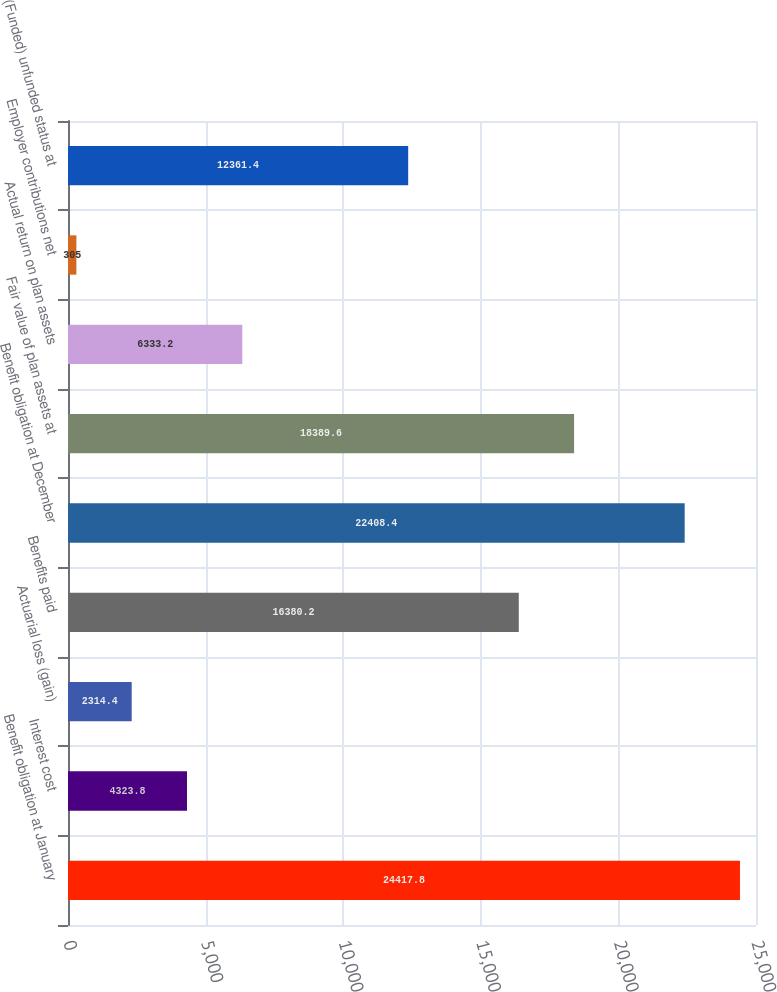<chart> <loc_0><loc_0><loc_500><loc_500><bar_chart><fcel>Benefit obligation at January<fcel>Interest cost<fcel>Actuarial loss (gain)<fcel>Benefits paid<fcel>Benefit obligation at December<fcel>Fair value of plan assets at<fcel>Actual return on plan assets<fcel>Employer contributions net<fcel>(Funded) unfunded status at<nl><fcel>24417.8<fcel>4323.8<fcel>2314.4<fcel>16380.2<fcel>22408.4<fcel>18389.6<fcel>6333.2<fcel>305<fcel>12361.4<nl></chart> 